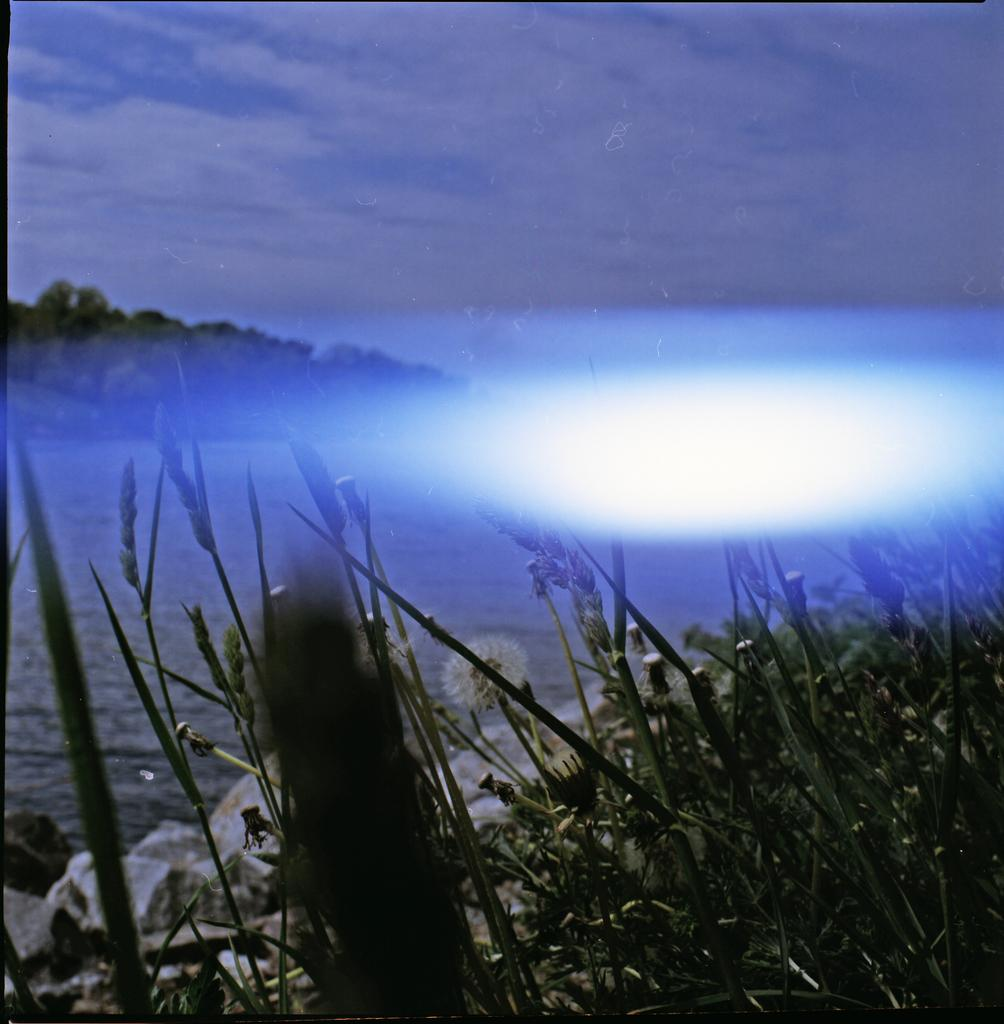What is located at the bottom of the image? There are plants at the bottom of the image. What is in the middle of the image? There is water in the middle of the image. What is visible at the top of the image? The sky is visible at the top of the image. How does the sky appear in the image? The sky appears to be cloudy in the image. Can you touch your aunt's kitten in the image? There is no aunt or kitten present in the image, so it is not possible to touch a kitten in the image. 